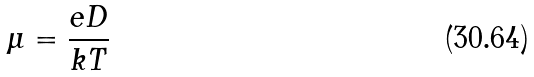Convert formula to latex. <formula><loc_0><loc_0><loc_500><loc_500>\mu = \frac { e D } { k T }</formula> 